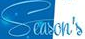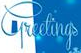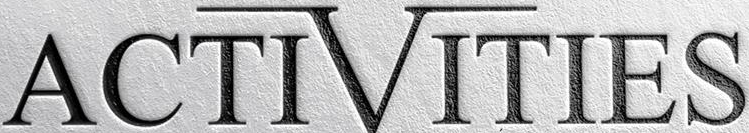Read the text content from these images in order, separated by a semicolon. Season's; Greetings; ACTIVITIES 